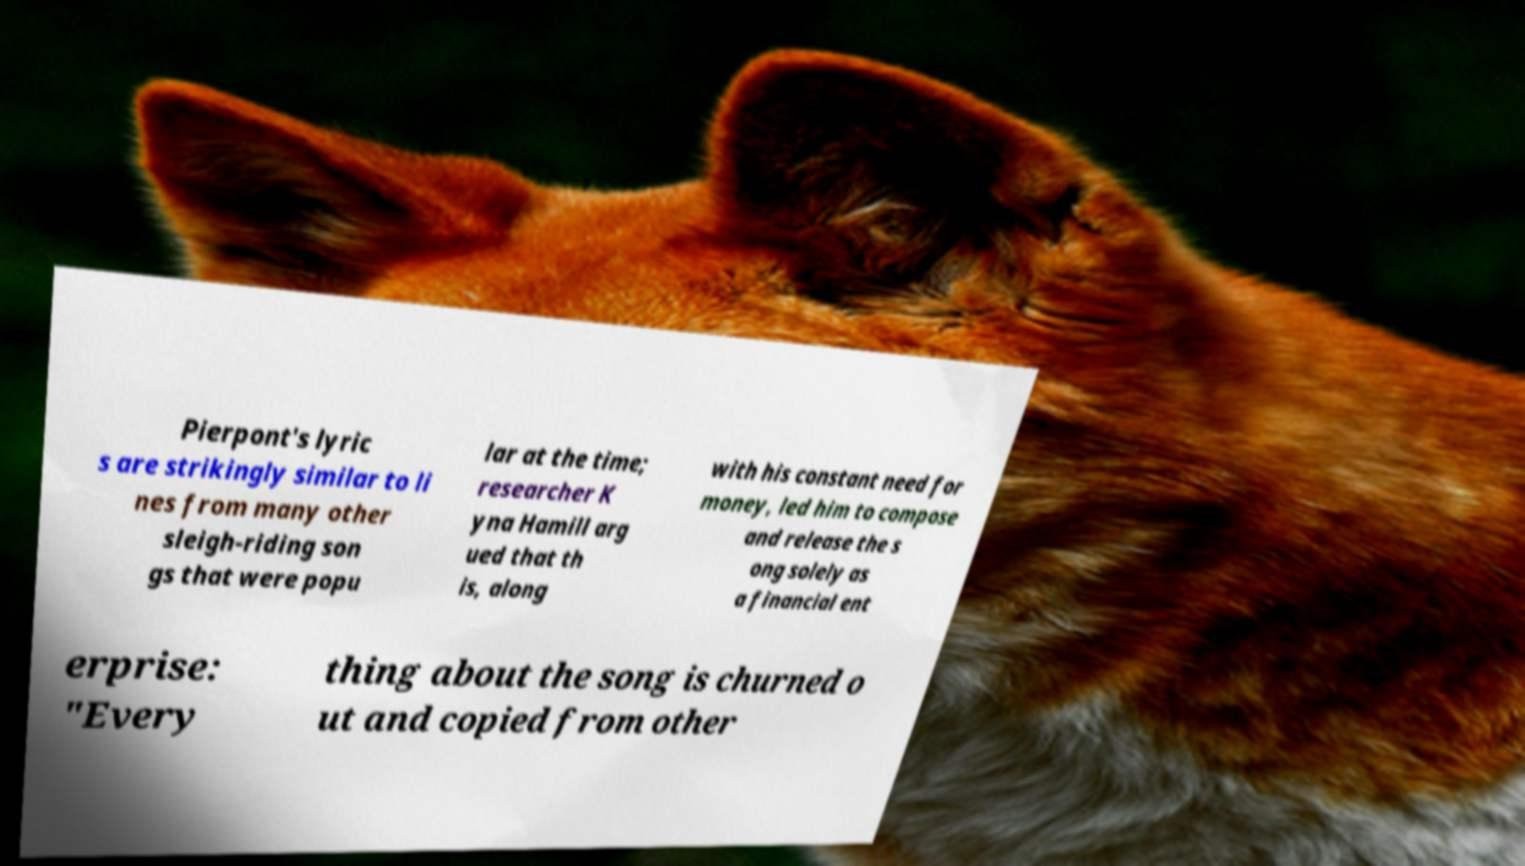Can you accurately transcribe the text from the provided image for me? Pierpont's lyric s are strikingly similar to li nes from many other sleigh-riding son gs that were popu lar at the time; researcher K yna Hamill arg ued that th is, along with his constant need for money, led him to compose and release the s ong solely as a financial ent erprise: "Every thing about the song is churned o ut and copied from other 